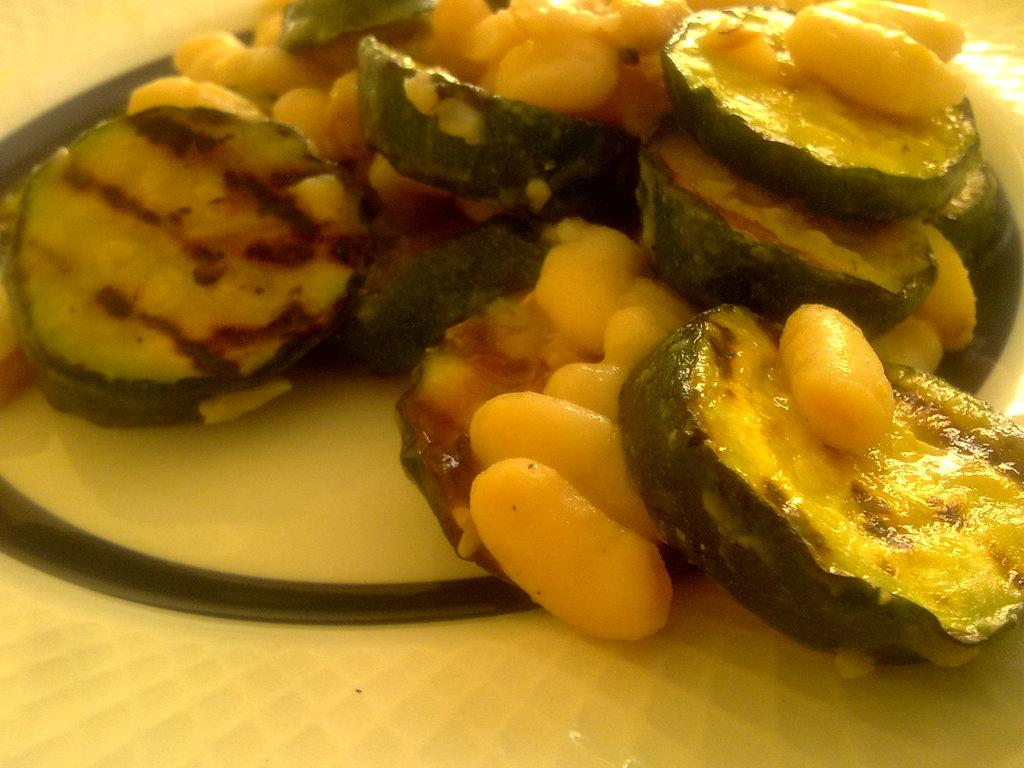What is the main subject of the image? There is a food item on a plate in the image. What type of system is being used to measure the spring's elasticity in the image? There is no system or spring present in the image; it only features a food item on a plate. 